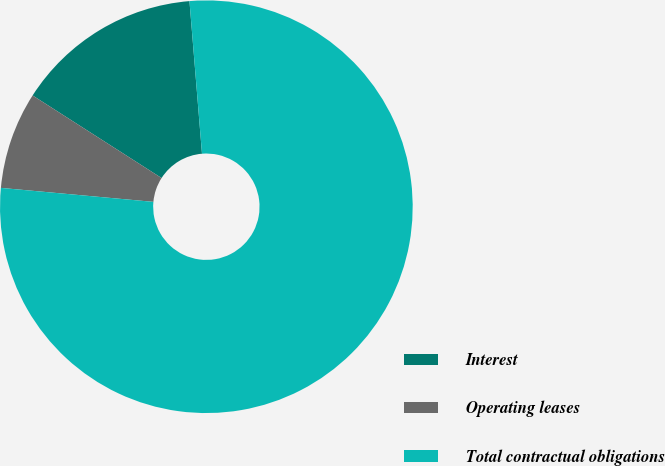Convert chart. <chart><loc_0><loc_0><loc_500><loc_500><pie_chart><fcel>Interest<fcel>Operating leases<fcel>Total contractual obligations<nl><fcel>14.63%<fcel>7.61%<fcel>77.76%<nl></chart> 